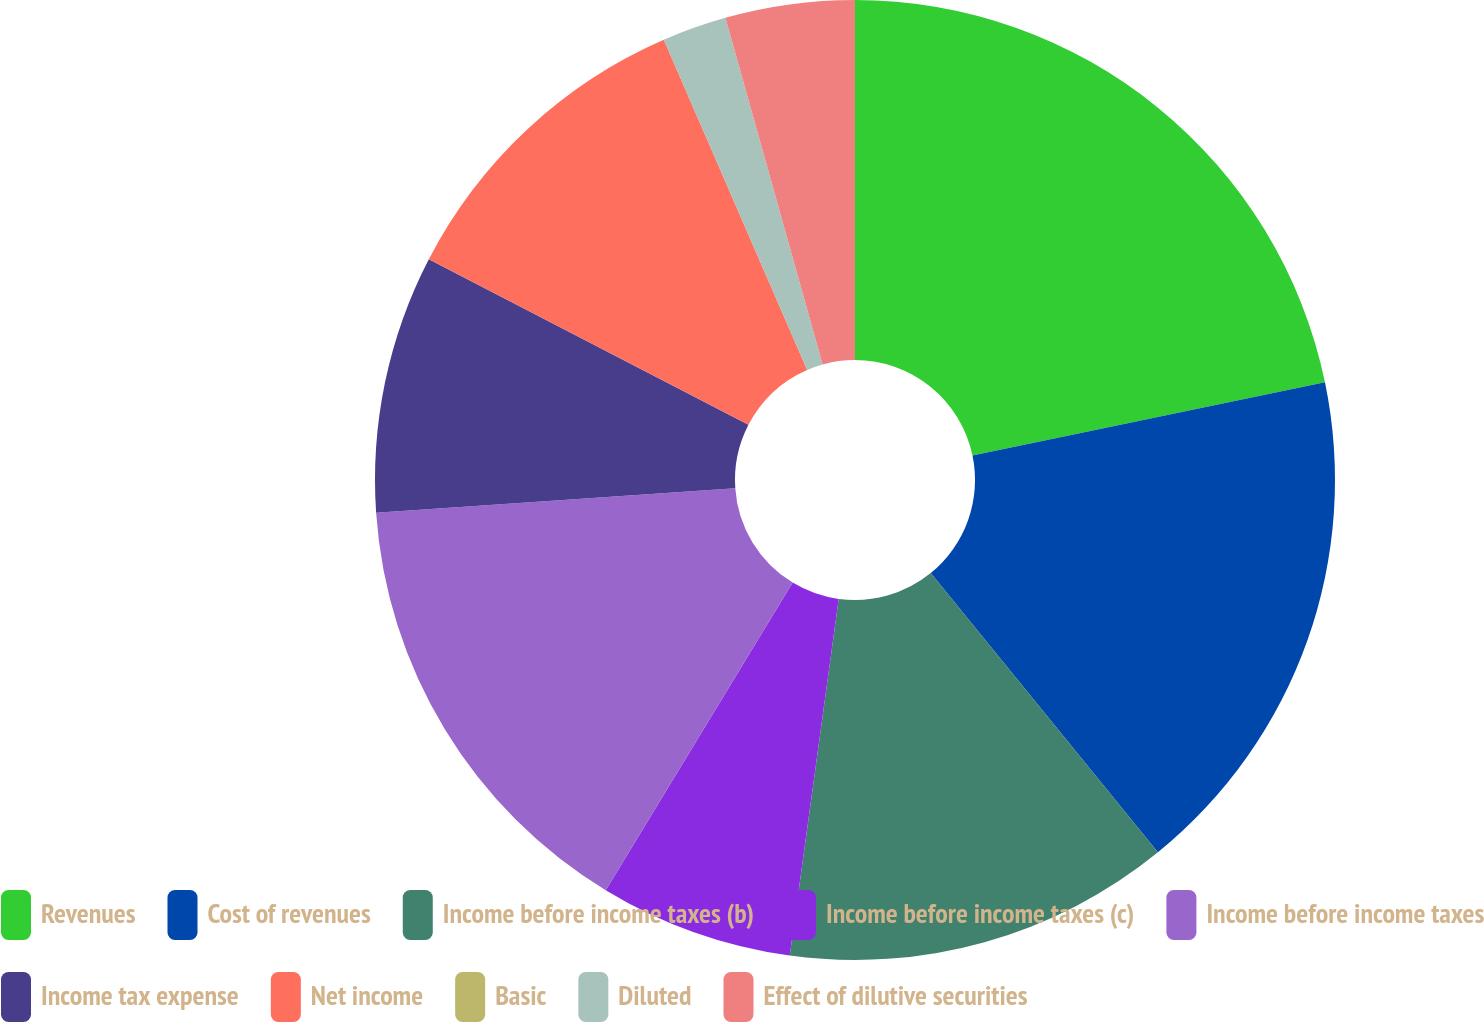Convert chart. <chart><loc_0><loc_0><loc_500><loc_500><pie_chart><fcel>Revenues<fcel>Cost of revenues<fcel>Income before income taxes (b)<fcel>Income before income taxes (c)<fcel>Income before income taxes<fcel>Income tax expense<fcel>Net income<fcel>Basic<fcel>Diluted<fcel>Effect of dilutive securities<nl><fcel>21.74%<fcel>17.39%<fcel>13.04%<fcel>6.52%<fcel>15.22%<fcel>8.7%<fcel>10.87%<fcel>0.0%<fcel>2.17%<fcel>4.35%<nl></chart> 